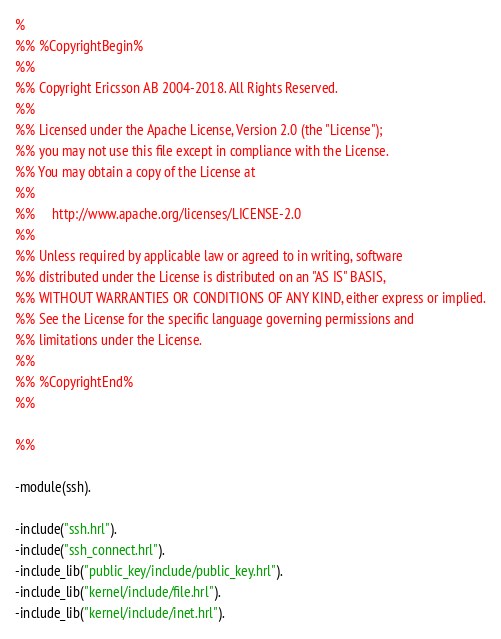Convert code to text. <code><loc_0><loc_0><loc_500><loc_500><_Erlang_>%
%% %CopyrightBegin%
%%
%% Copyright Ericsson AB 2004-2018. All Rights Reserved.
%%
%% Licensed under the Apache License, Version 2.0 (the "License");
%% you may not use this file except in compliance with the License.
%% You may obtain a copy of the License at
%%
%%     http://www.apache.org/licenses/LICENSE-2.0
%%
%% Unless required by applicable law or agreed to in writing, software
%% distributed under the License is distributed on an "AS IS" BASIS,
%% WITHOUT WARRANTIES OR CONDITIONS OF ANY KIND, either express or implied.
%% See the License for the specific language governing permissions and
%% limitations under the License.
%%
%% %CopyrightEnd%
%%

%%

-module(ssh).

-include("ssh.hrl").
-include("ssh_connect.hrl").
-include_lib("public_key/include/public_key.hrl").
-include_lib("kernel/include/file.hrl").
-include_lib("kernel/include/inet.hrl").
</code> 